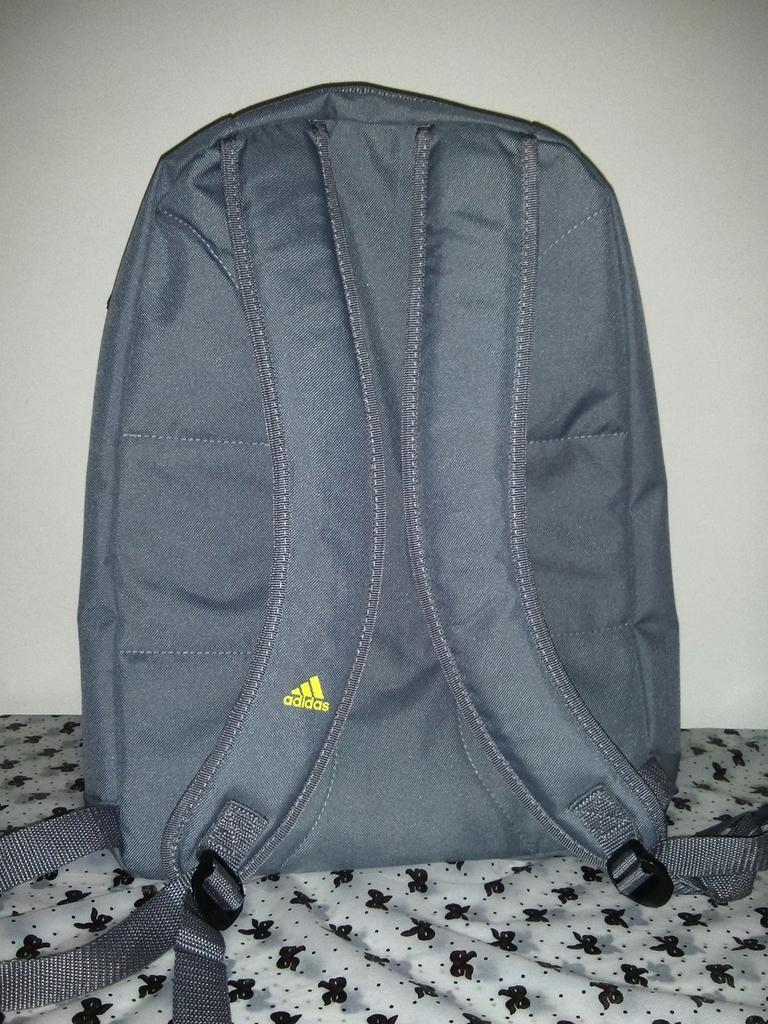<image>
Render a clear and concise summary of the photo. a grey Adidas backpack with a yellow logo on the strap 